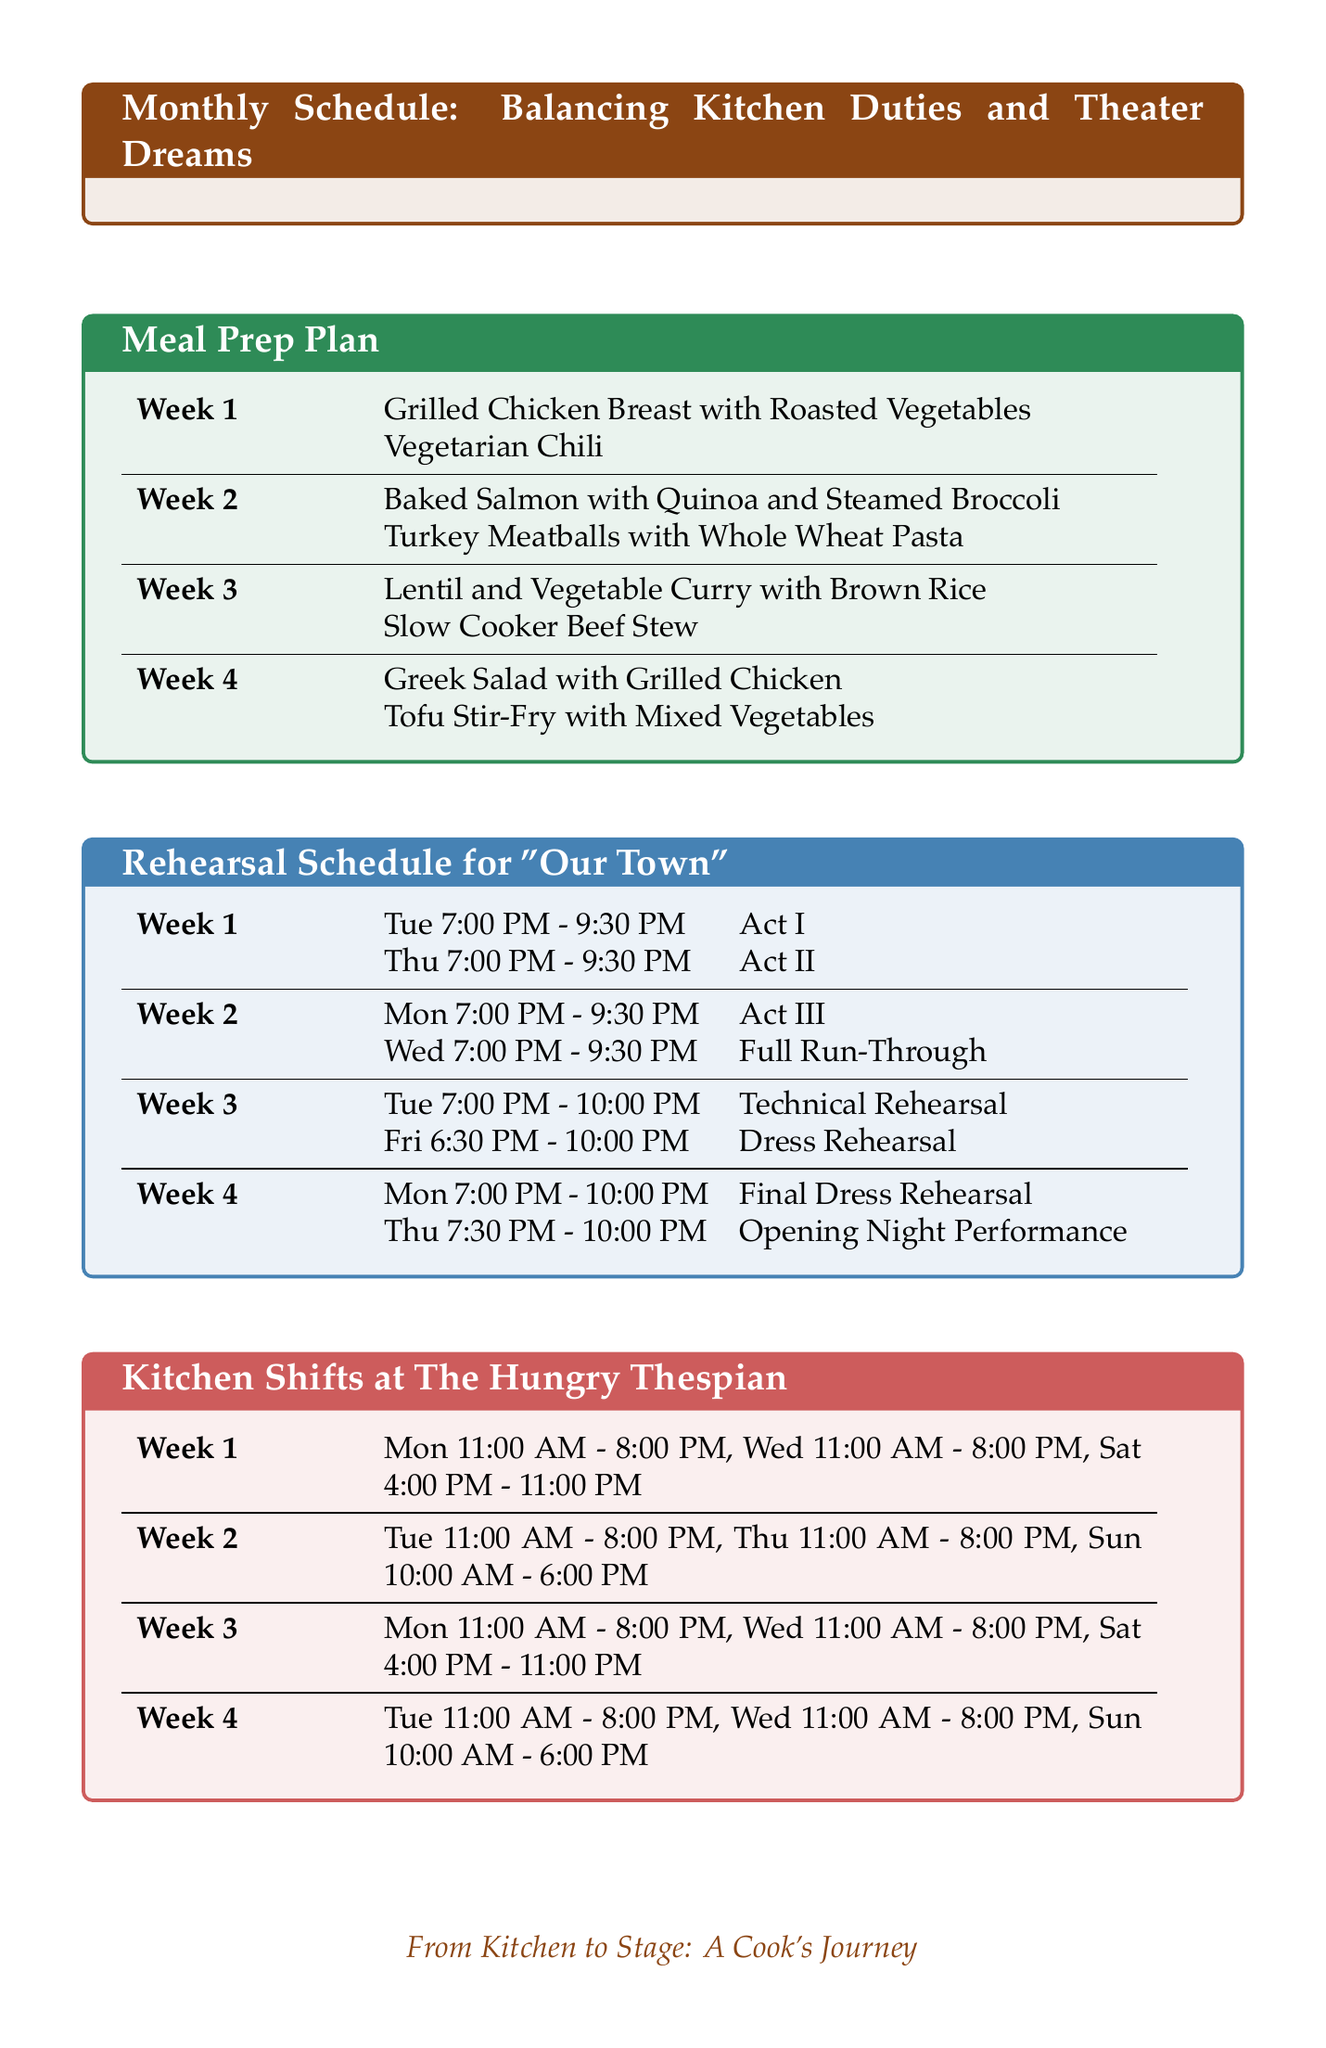What dish is prepared in Week 1? The dish prepared in Week 1 is listed under the Meal Prep Plan section of the document.
Answer: Grilled Chicken Breast with Roasted Vegetables What ingredient is used in the Vegetarian Chili? The Vegetarian Chili's ingredients are provided in the Meal Prep Plan section.
Answer: Beans What is the rehearsal day for Act III? The rehearsal days for each act are detailed in the Rehearsal Schedule for "Our Town" section.
Answer: Monday How many shifts are scheduled for Week 4? The number of shifts for Week 4 can be identified by counting the entries in the Kitchen Shifts section.
Answer: Three What time does the Opening Night Performance begin? The Opening Night Performance time is specified in the Rehearsal Schedule for "Our Town."
Answer: 7:30 PM Which meal is prepared on the same day as the Final Dress Rehearsal? The meals and their prep days are documented in the Meal Prep Plan, and the rehearsal schedule shows the date of the Final Dress Rehearsal.
Answer: Greek Salad with Grilled Chicken What is the location of the rehearsals? The location for all rehearsals is mentioned in the document.
Answer: Civic Theater In which week is the Turkey Meatballs dish planned? The Meal Prep Plan section outlines which dish corresponds to each week.
Answer: Week 2 